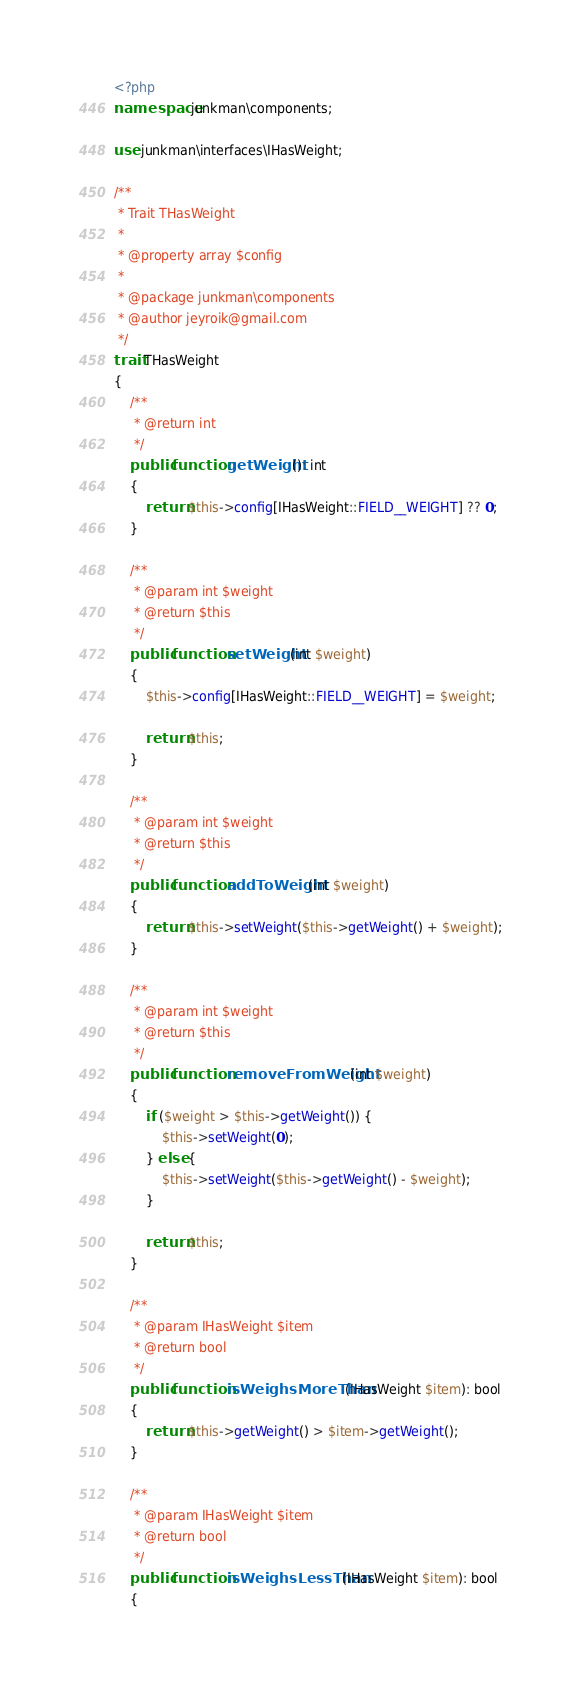<code> <loc_0><loc_0><loc_500><loc_500><_PHP_><?php
namespace junkman\components;

use junkman\interfaces\IHasWeight;

/**
 * Trait THasWeight
 *
 * @property array $config
 *
 * @package junkman\components
 * @author jeyroik@gmail.com
 */
trait THasWeight
{
    /**
     * @return int
     */
    public function getWeight(): int
    {
        return $this->config[IHasWeight::FIELD__WEIGHT] ?? 0;
    }

    /**
     * @param int $weight
     * @return $this
     */
    public function setWeight(int $weight)
    {
        $this->config[IHasWeight::FIELD__WEIGHT] = $weight;

        return $this;
    }

    /**
     * @param int $weight
     * @return $this
     */
    public function addToWeight(int $weight)
    {
        return $this->setWeight($this->getWeight() + $weight);
    }

    /**
     * @param int $weight
     * @return $this
     */
    public function removeFromWeight(int $weight)
    {
        if ($weight > $this->getWeight()) {
            $this->setWeight(0);
        } else {
            $this->setWeight($this->getWeight() - $weight);
        }

        return $this;
    }

    /**
     * @param IHasWeight $item
     * @return bool
     */
    public function isWeighsMoreThan(IHasWeight $item): bool
    {
        return $this->getWeight() > $item->getWeight();
    }

    /**
     * @param IHasWeight $item
     * @return bool
     */
    public function isWeighsLessThan(IHasWeight $item): bool
    {</code> 